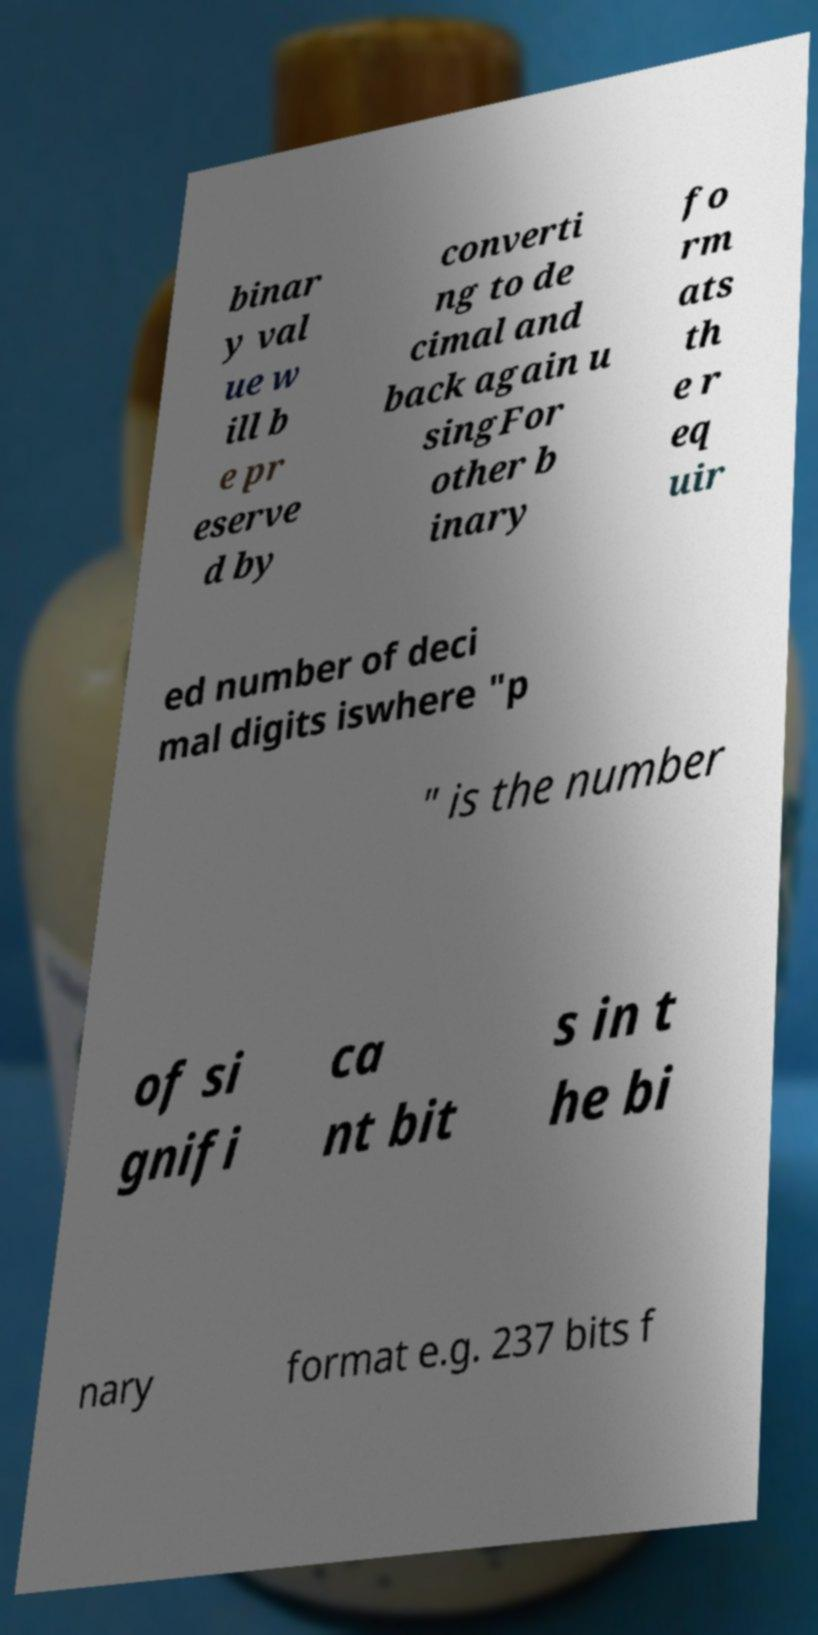Please read and relay the text visible in this image. What does it say? binar y val ue w ill b e pr eserve d by converti ng to de cimal and back again u singFor other b inary fo rm ats th e r eq uir ed number of deci mal digits iswhere "p " is the number of si gnifi ca nt bit s in t he bi nary format e.g. 237 bits f 